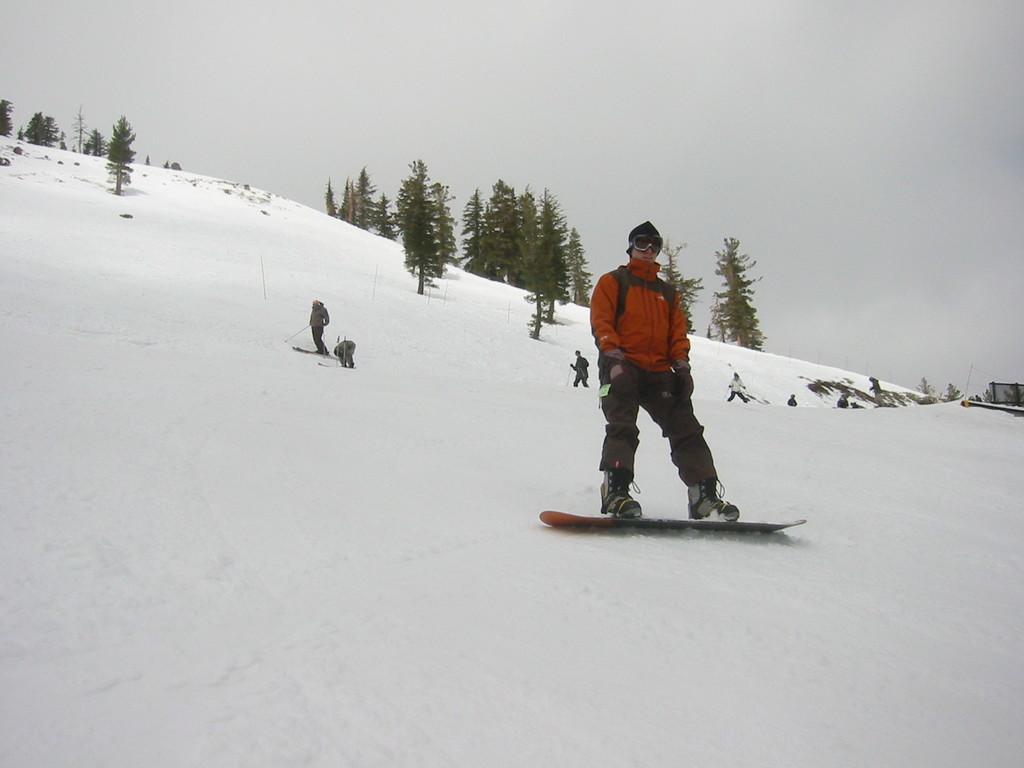Describe this image in one or two sentences. The picture is taken in a snowy area. In the foreground picture there is a person skiing. In the center of the picture there are many people skiing. At the top there are trees. Sky is cloudy. 